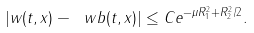Convert formula to latex. <formula><loc_0><loc_0><loc_500><loc_500>| w ( t , x ) - \ w b ( t , x ) | \leq C e ^ { - \mu R _ { 1 } ^ { 2 } + R _ { 2 } ^ { 2 } / 2 } .</formula> 